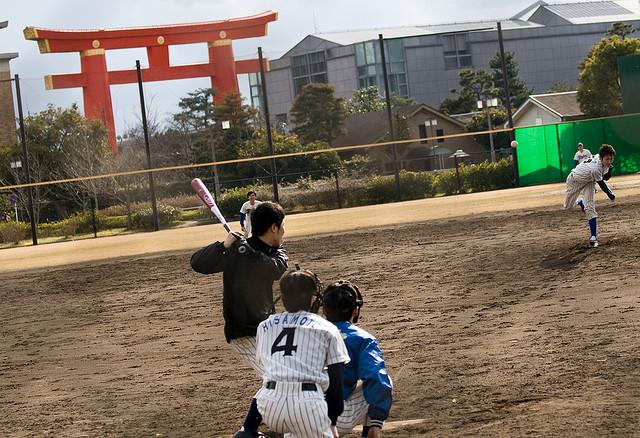What is the boy throwing?
Concise answer only. Ball. What sport is this?
Short answer required. Baseball. What is the boy in black doing?
Keep it brief. Batting. 